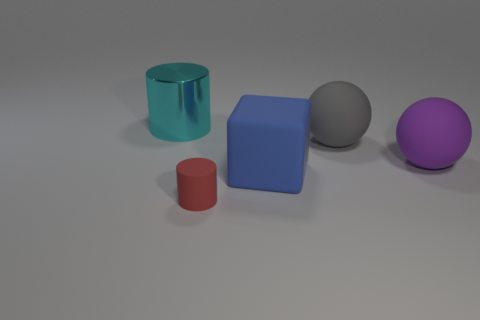Is there anything else that has the same size as the rubber cylinder?
Your answer should be compact. No. Are there more large metal cylinders than large rubber things?
Your answer should be compact. No. How big is the thing that is both on the left side of the big blue rubber object and in front of the large metal thing?
Provide a succinct answer. Small. The cyan metal object is what shape?
Your answer should be compact. Cylinder. How many big cyan metallic objects are the same shape as the blue rubber thing?
Keep it short and to the point. 0. Are there fewer blue matte blocks to the right of the blue block than small cylinders that are in front of the shiny object?
Offer a very short reply. Yes. There is a sphere that is in front of the gray rubber ball; how many cyan things are on the left side of it?
Ensure brevity in your answer.  1. Are there any large yellow metal balls?
Provide a succinct answer. No. Are there any tiny red objects made of the same material as the large cube?
Keep it short and to the point. Yes. Is the number of big things that are left of the purple rubber sphere greater than the number of purple spheres in front of the small object?
Your answer should be compact. Yes. 